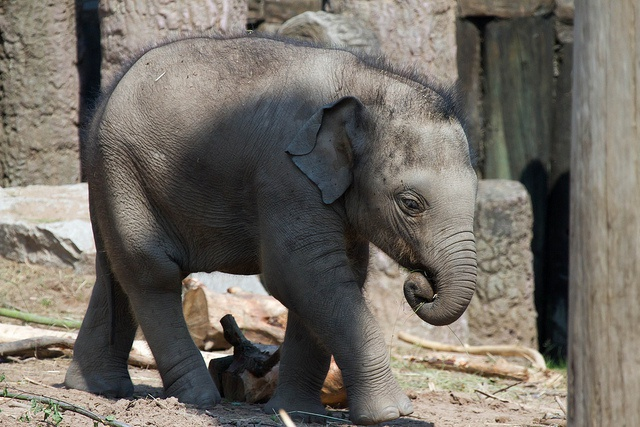Describe the objects in this image and their specific colors. I can see a elephant in gray, black, and darkgray tones in this image. 